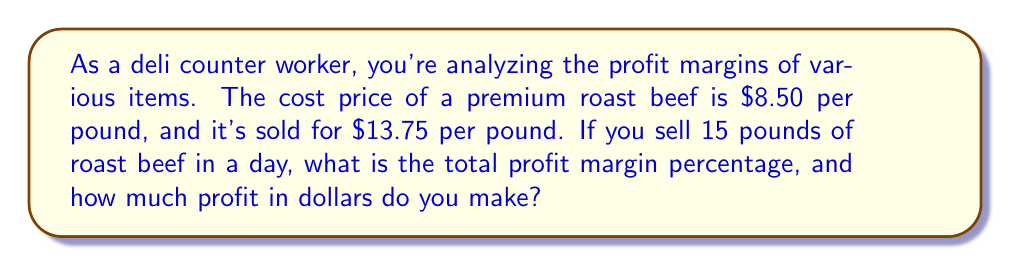Give your solution to this math problem. Let's break this down step-by-step:

1) First, let's calculate the profit per pound:
   Selling price - Cost price = Profit per pound
   $13.75 - $8.50 = $5.25 per pound

2) To calculate the profit margin percentage, we use the formula:
   $$ \text{Profit Margin} = \frac{\text{Profit}}{\text{Selling Price}} \times 100\% $$

   $$ \text{Profit Margin} = \frac{5.25}{13.75} \times 100\% = 38.18\% $$

3) Now, let's calculate the total profit for 15 pounds:
   Profit per pound × Number of pounds = Total profit
   $5.25 × 15 = $78.75

Therefore, the profit margin percentage is 38.18%, and the total profit for selling 15 pounds of roast beef is $78.75.
Answer: 38.18%, $78.75 